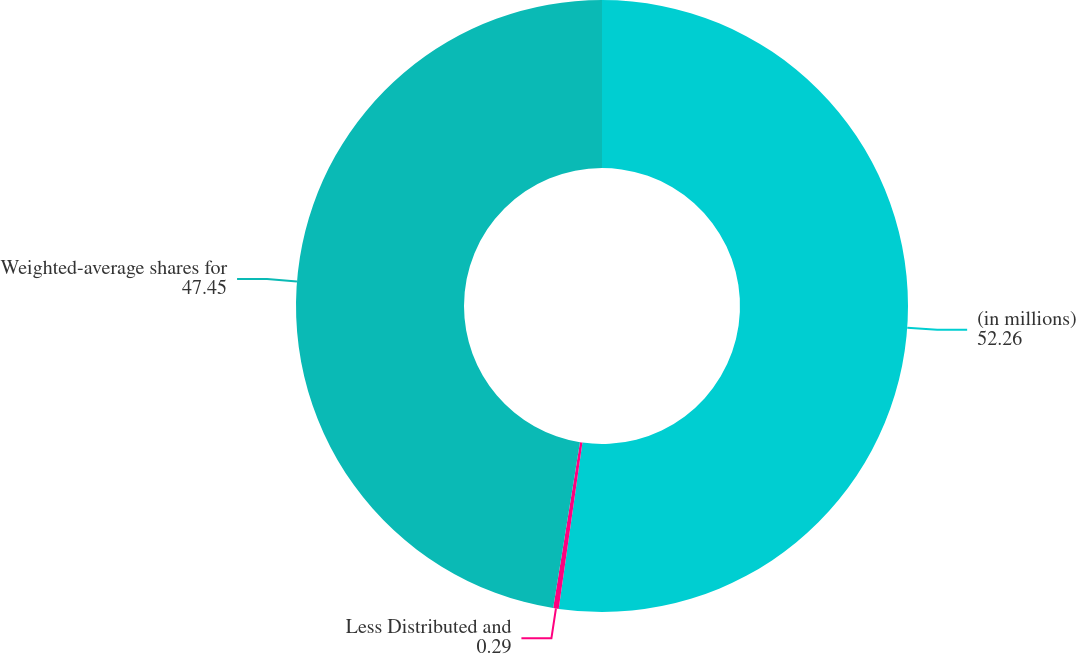Convert chart to OTSL. <chart><loc_0><loc_0><loc_500><loc_500><pie_chart><fcel>(in millions)<fcel>Less Distributed and<fcel>Weighted-average shares for<nl><fcel>52.26%<fcel>0.29%<fcel>47.45%<nl></chart> 